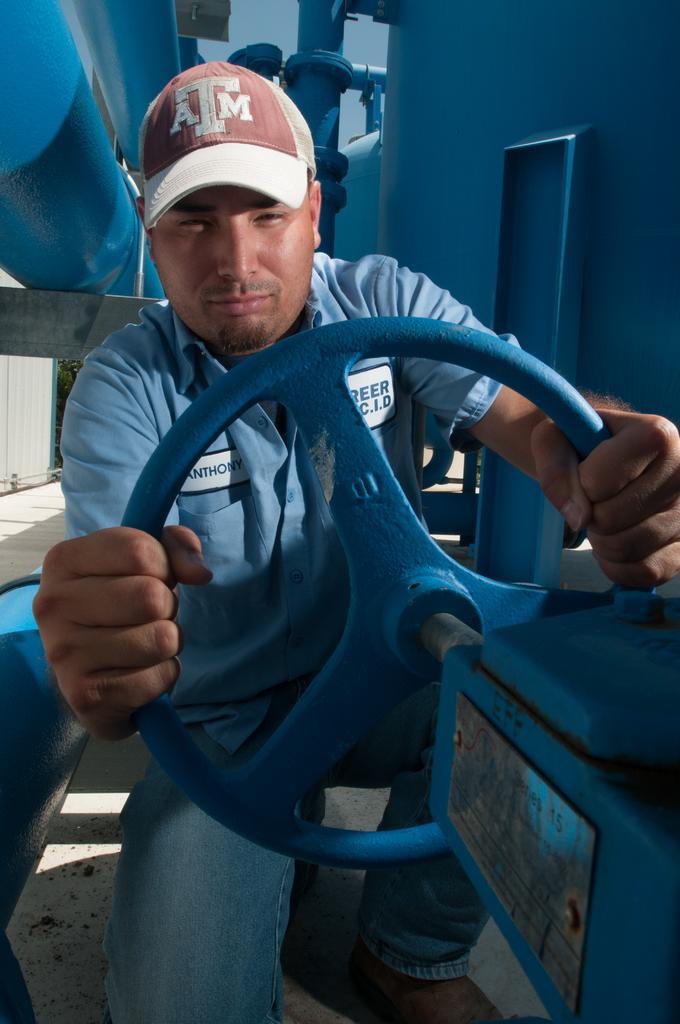In one or two sentences, can you explain what this image depicts? In the picture we can see a man sitting on the knee and holding a steering and he is in blue T-shirt and cap and beside him we can see a wall with a door which is also blue in color and beside the wall we can see some pipes. 